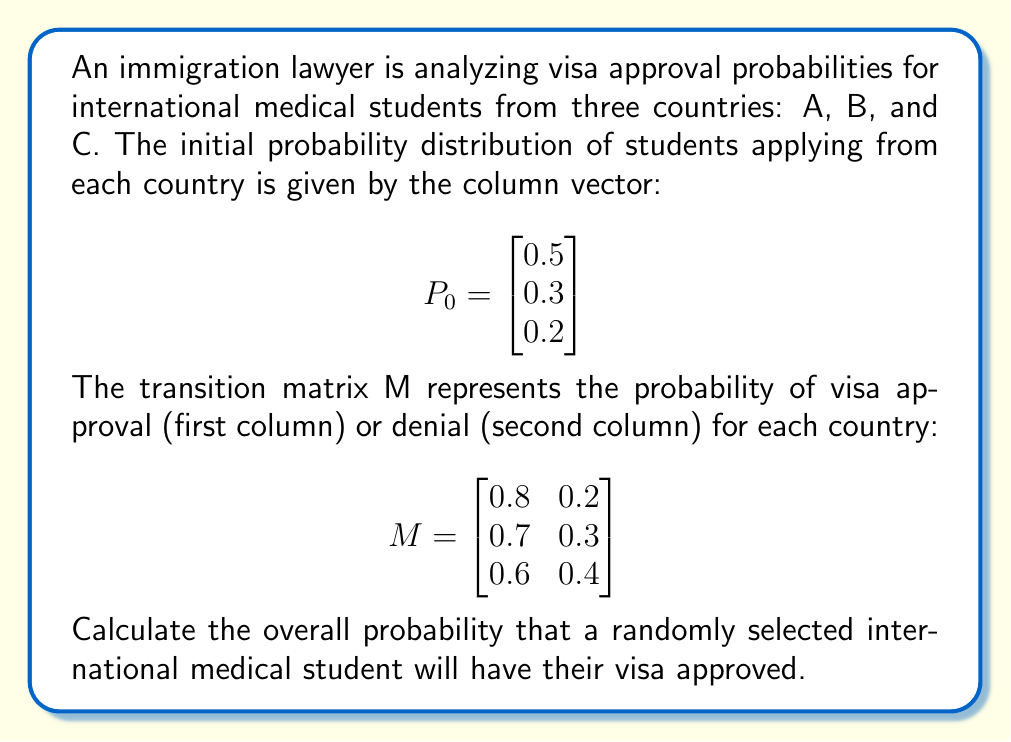Teach me how to tackle this problem. To solve this problem, we need to follow these steps:

1) First, we need to understand what the given information represents:
   - $P_0$ is the initial probability distribution of students from each country.
   - M is the transition matrix, where each row represents the probabilities for a country, and the columns represent approval (1st) and denial (2nd).

2) To find the overall probability of visa approval, we need to multiply the initial distribution by the first column of the transition matrix (which represents approval probabilities).

3) We can extract the first column of M as a new matrix:

   $$M_{approval} = \begin{bmatrix} 0.8 \\ 0.7 \\ 0.6 \end{bmatrix}$$

4) Now, we perform matrix multiplication between $P_0^T$ (transposed to a row vector) and $M_{approval}$:

   $$P(\text{approval}) = P_0^T \cdot M_{approval}$$

5) Let's carry out this multiplication:

   $$\begin{align}
   P(\text{approval}) &= \begin{bmatrix} 0.5 & 0.3 & 0.2 \end{bmatrix} \cdot \begin{bmatrix} 0.8 \\ 0.7 \\ 0.6 \end{bmatrix} \\
   &= (0.5 \times 0.8) + (0.3 \times 0.7) + (0.2 \times 0.6) \\
   &= 0.4 + 0.21 + 0.12 \\
   &= 0.73
   \end{align}$$

Therefore, the overall probability that a randomly selected international medical student will have their visa approved is 0.73 or 73%.
Answer: 0.73 or 73% 